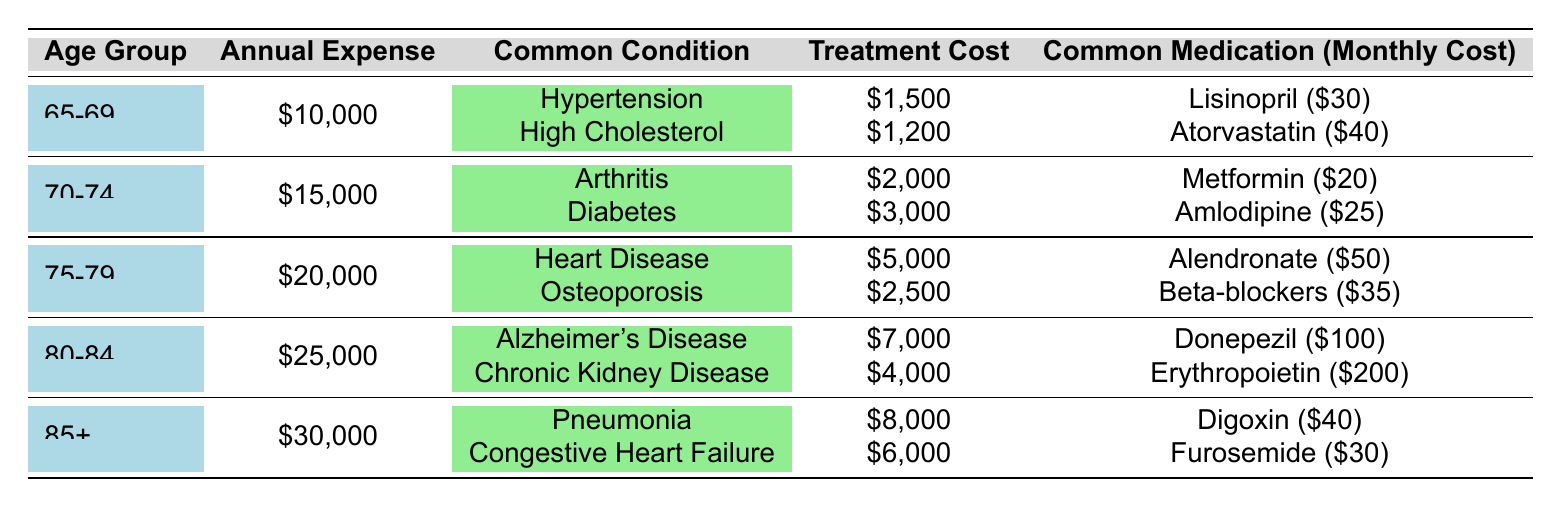What is the average annual healthcare expense for retirees aged 70-74? The average annual expense for the age group 70-74 is listed in the table as $15,000.
Answer: $15,000 Which common condition has the highest treatment cost for retirees aged 80-84? In the 80-84 age group, Alzheimer's Disease has the highest treatment cost at $7,000.
Answer: Alzheimer's Disease Calculate the total monthly cost of medications for retirees aged 75-79. The monthly costs for medications in the 75-79 age group are Alendronate ($50) and Beta-blockers ($35). Adding these gives 50 + 35 = 85.
Answer: $85 Is the average annual expense for the age group 85+ higher than that for the age group 75-79? The average annual expense for 85+ is $30,000, while for 75-79 it is $20,000. Since $30,000 is greater than $20,000, the statement is true.
Answer: Yes What is the difference in average annual expenses between the age groups 70-74 and 80-84? The average annual expense for 70-74 is $15,000 and for 80-84 is $25,000. The difference is calculated as 25,000 - 15,000 = 10,000.
Answer: $10,000 List the medications for the age group 65-69 along with their monthly costs. In the 65-69 age group, the medications are Lisinopril costing $30/month and Atorvastatin costing $40/month.
Answer: Lisinopril ($30), Atorvastatin ($40) What are the two most common conditions for retirees aged 75-79? The most common conditions for the 75-79 age group are Heart Disease and Osteoporosis.
Answer: Heart Disease, Osteoporosis If a retiree aged 80-84 takes both prescribed medications, what is their total monthly cost? The total monthly costs for the age group 80-84 are Donepezil at $100 and Erythropoietin at $200. Adding them gives 100 + 200 = 300.
Answer: $300 How much do retirees aged 65-69 spend on treatment for High Cholesterol? The treatment cost for High Cholesterol in the 65-69 age group is $1,200, as indicated in the table.
Answer: $1,200 Does the age group 75-79 have a higher average annual expense than the 70-74 group? The average annual expense for 75-79 is $20,000 and for 70-74 it is $15,000. Since $20,000 is greater than $15,000, the statement is true.
Answer: Yes 